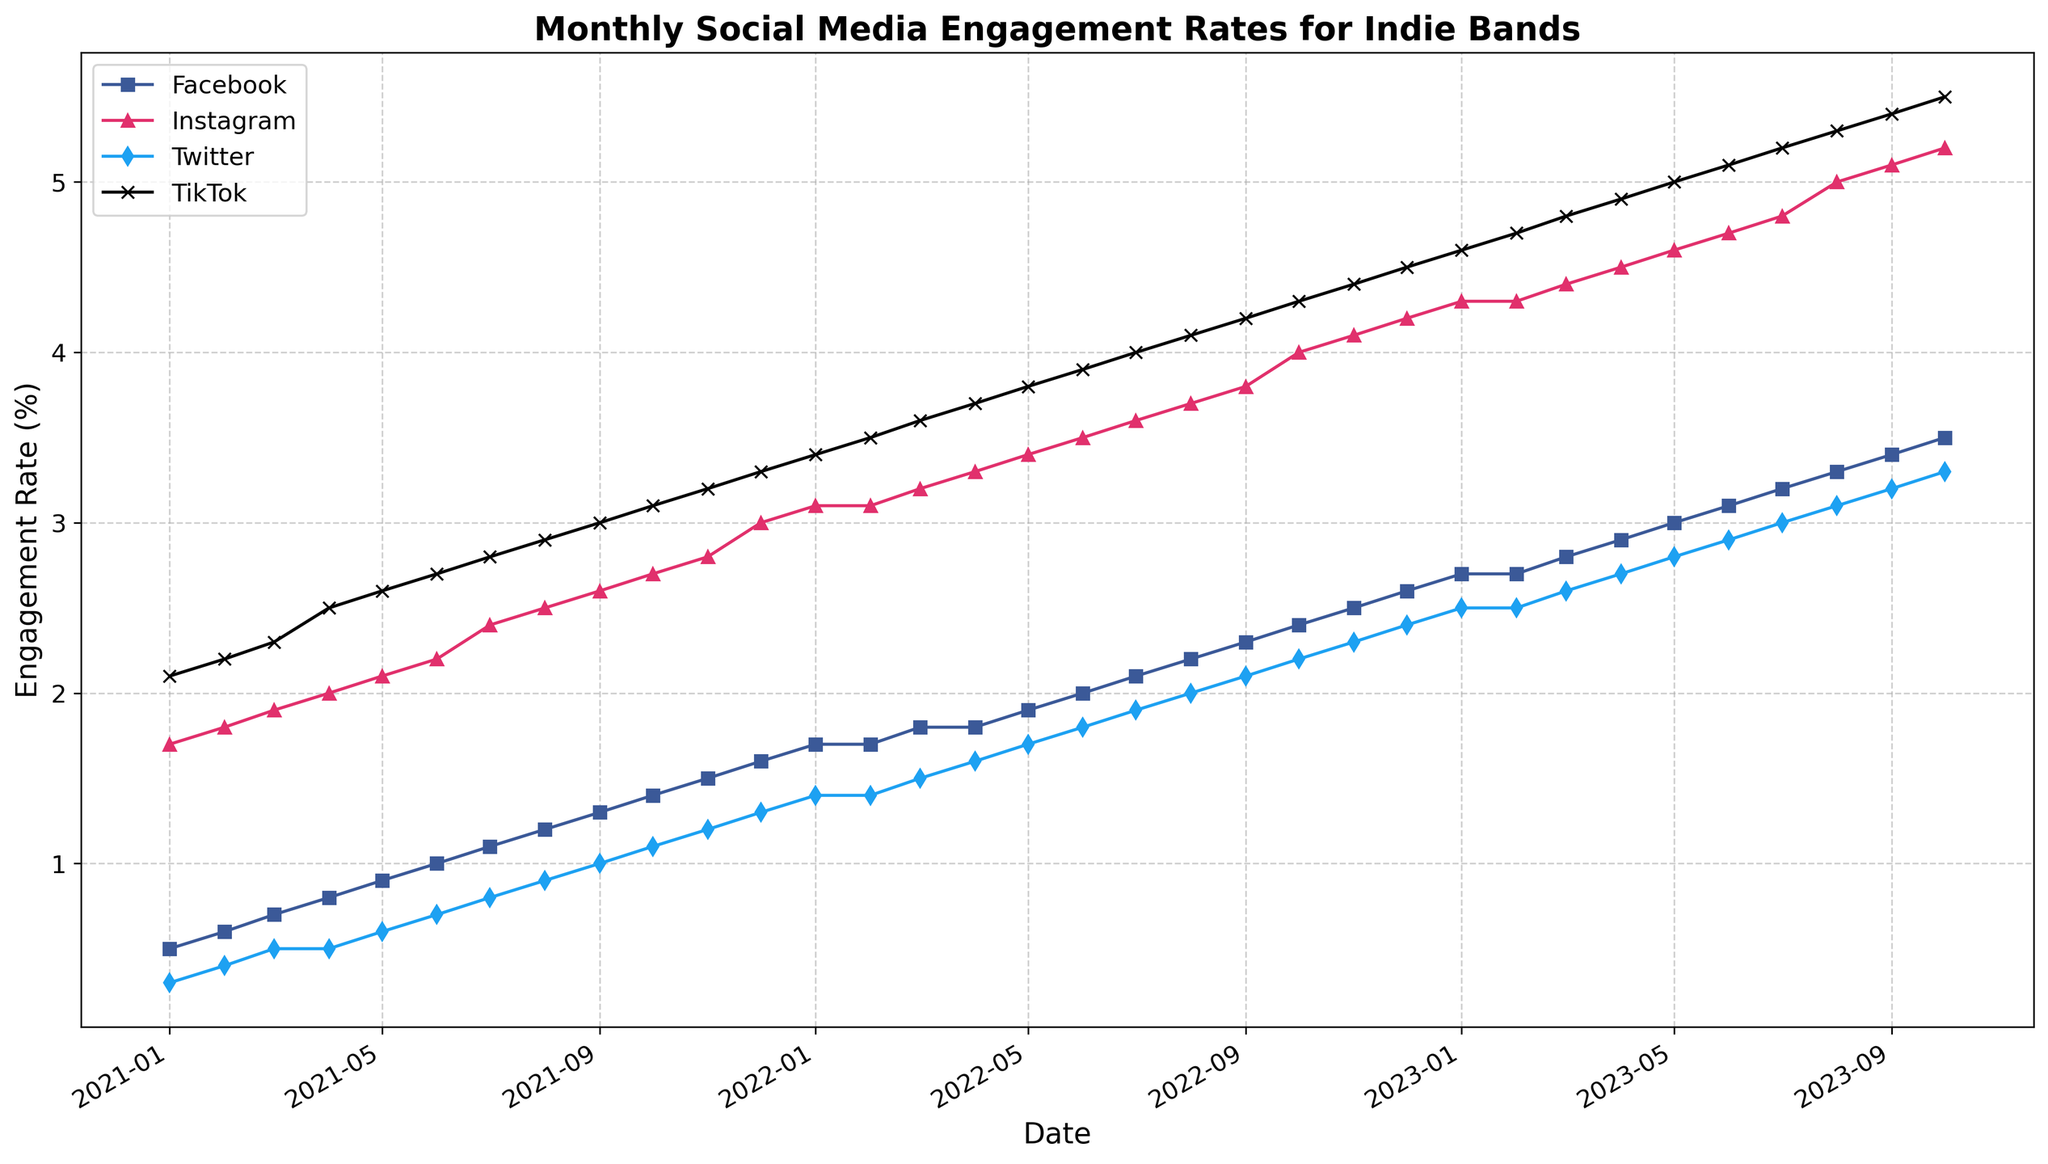what is the average TikTok engagement rate in 2022? Sum the monthly TikTok engagement rates for 2022 and divide by the number of months: (3.4 + 3.5 + 3.6 + 3.7 + 3.8 + 3.9 + 4.0 + 4.1 + 4.2 + 4.3 + 4.4 + 4.5) / 12 = 3.825
Answer: 3.825 which platform had the highest engagement rate in October 2023? Compare the engagement rates for all platforms in October 2023 and identify the largest one: Facebook (3.5), Instagram (5.2), Twitter (3.3), TikTok (5.5). TikTok has the highest rate.
Answer: TikTok how much did Facebook's engagement rate increase from January 2021 to January 2023? Subtract the engagement rate in January 2021 from the rate in January 2023: 2.7 - 0.5 = 2.2
Answer: 2.2 what’s the difference in Instagram engagement rates between December 2022 and December 2021? Subtract the engagement rate in December 2021 from December 2022: 4.2 - 3.0 = 1.2
Answer: 1.2 which platform showed the most consistent engagement growth over the two years? Evaluate each platform's engagement growth trend over the two years. All platforms show steady growth, but TikTok consistently has larger increments each month.
Answer: TikTok during which month did Twitter first reach an engagement rate of 2%? Find the first month where Twitter's engagement rate reaches 2%: This happens in August 2022.
Answer: August 2022 among the four platforms, which had the slowest growth in engagement rate from January 2021 to October 2023? Compare the initial and final engagement rates for all platforms between January 2021 and October 2023 to identify the one with the smallest increase. Facebook grew from 0.5% to 3.5%, which is the smallest relative increase compared to other platforms.
Answer: Facebook what is the trend of Instagram’s engagement rate from July 2021 to July 2022? Describe Instagram's engagement rates trend from July 2021 (2.4%) to July 2022 (3.6%). The rate shows consistent growth each month.
Answer: consistent growth which month in 2021 did TikTok surpass 3% engagement rate? Identify the month in 2021 when TikTok engagement rate exceeded 3% for the first time: This happened in September 2021.
Answer: September 2021 